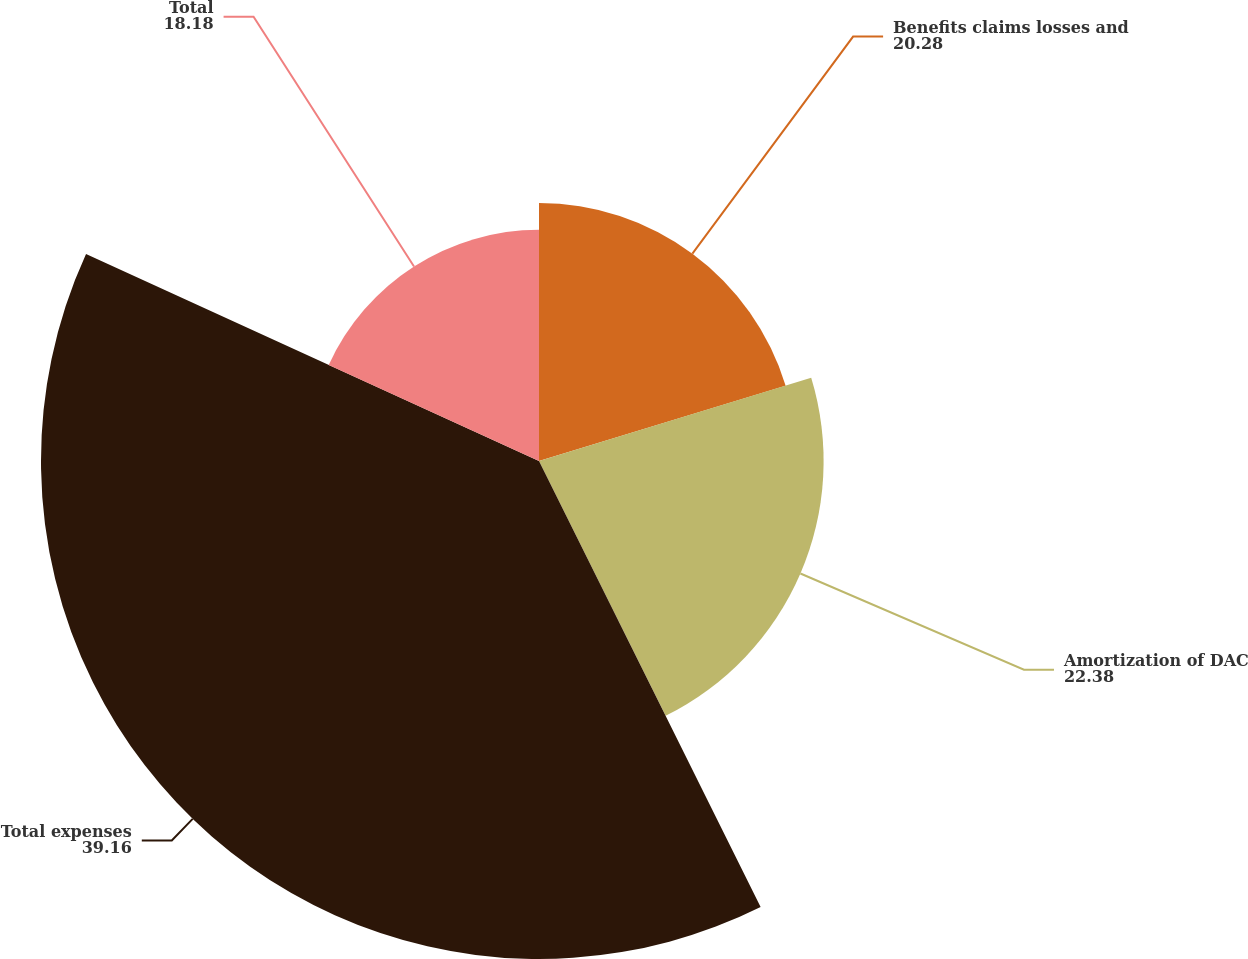Convert chart. <chart><loc_0><loc_0><loc_500><loc_500><pie_chart><fcel>Benefits claims losses and<fcel>Amortization of DAC<fcel>Total expenses<fcel>Total<nl><fcel>20.28%<fcel>22.38%<fcel>39.16%<fcel>18.18%<nl></chart> 